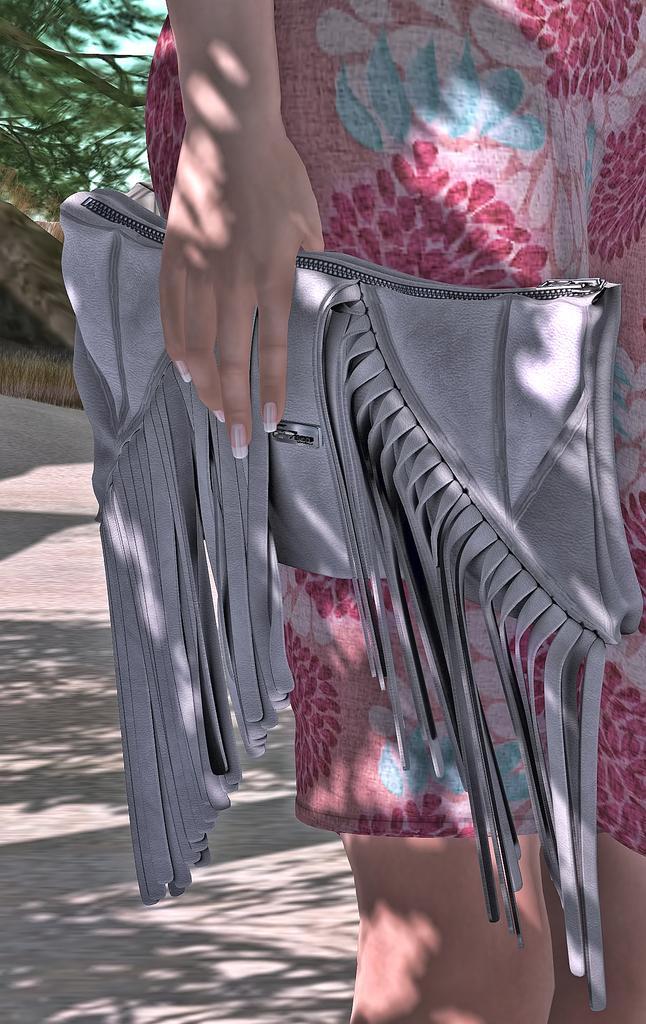How would you summarize this image in a sentence or two? In this image there is a person standing, person is truncated, a person is holding a purse, there is the road, there is an object truncated towards the left of the image, there is tree truncated towards the left of the image, there is the sky. 